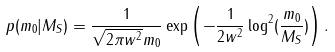Convert formula to latex. <formula><loc_0><loc_0><loc_500><loc_500>p ( m _ { 0 } | M _ { S } ) = \frac { 1 } { \sqrt { 2 \pi w ^ { 2 } } m _ { 0 } } \exp \left ( - \frac { 1 } { 2 w ^ { 2 } } \log ^ { 2 } ( \frac { m _ { 0 } } { M _ { S } } ) \right ) .</formula> 